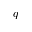<formula> <loc_0><loc_0><loc_500><loc_500>q</formula> 